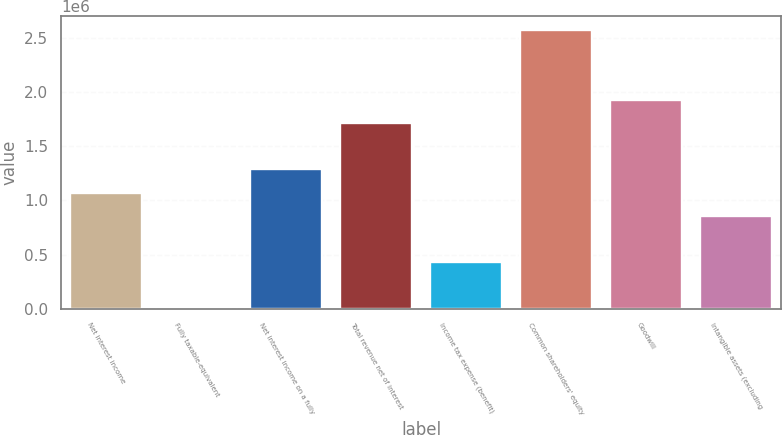<chart> <loc_0><loc_0><loc_500><loc_500><bar_chart><fcel>Net interest income<fcel>Fully taxable-equivalent<fcel>Net interest income on a fully<fcel>Total revenue net of interest<fcel>Income tax expense (benefit)<fcel>Common shareholders' equity<fcel>Goodwill<fcel>Intangible assets (excluding<nl><fcel>1.07188e+06<fcel>219<fcel>1.28621e+06<fcel>1.71488e+06<fcel>428884<fcel>2.57221e+06<fcel>1.92921e+06<fcel>857549<nl></chart> 